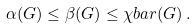Convert formula to latex. <formula><loc_0><loc_0><loc_500><loc_500>\alpha ( G ) \leq \beta ( G ) \leq \chi b a r ( G ) \, .</formula> 